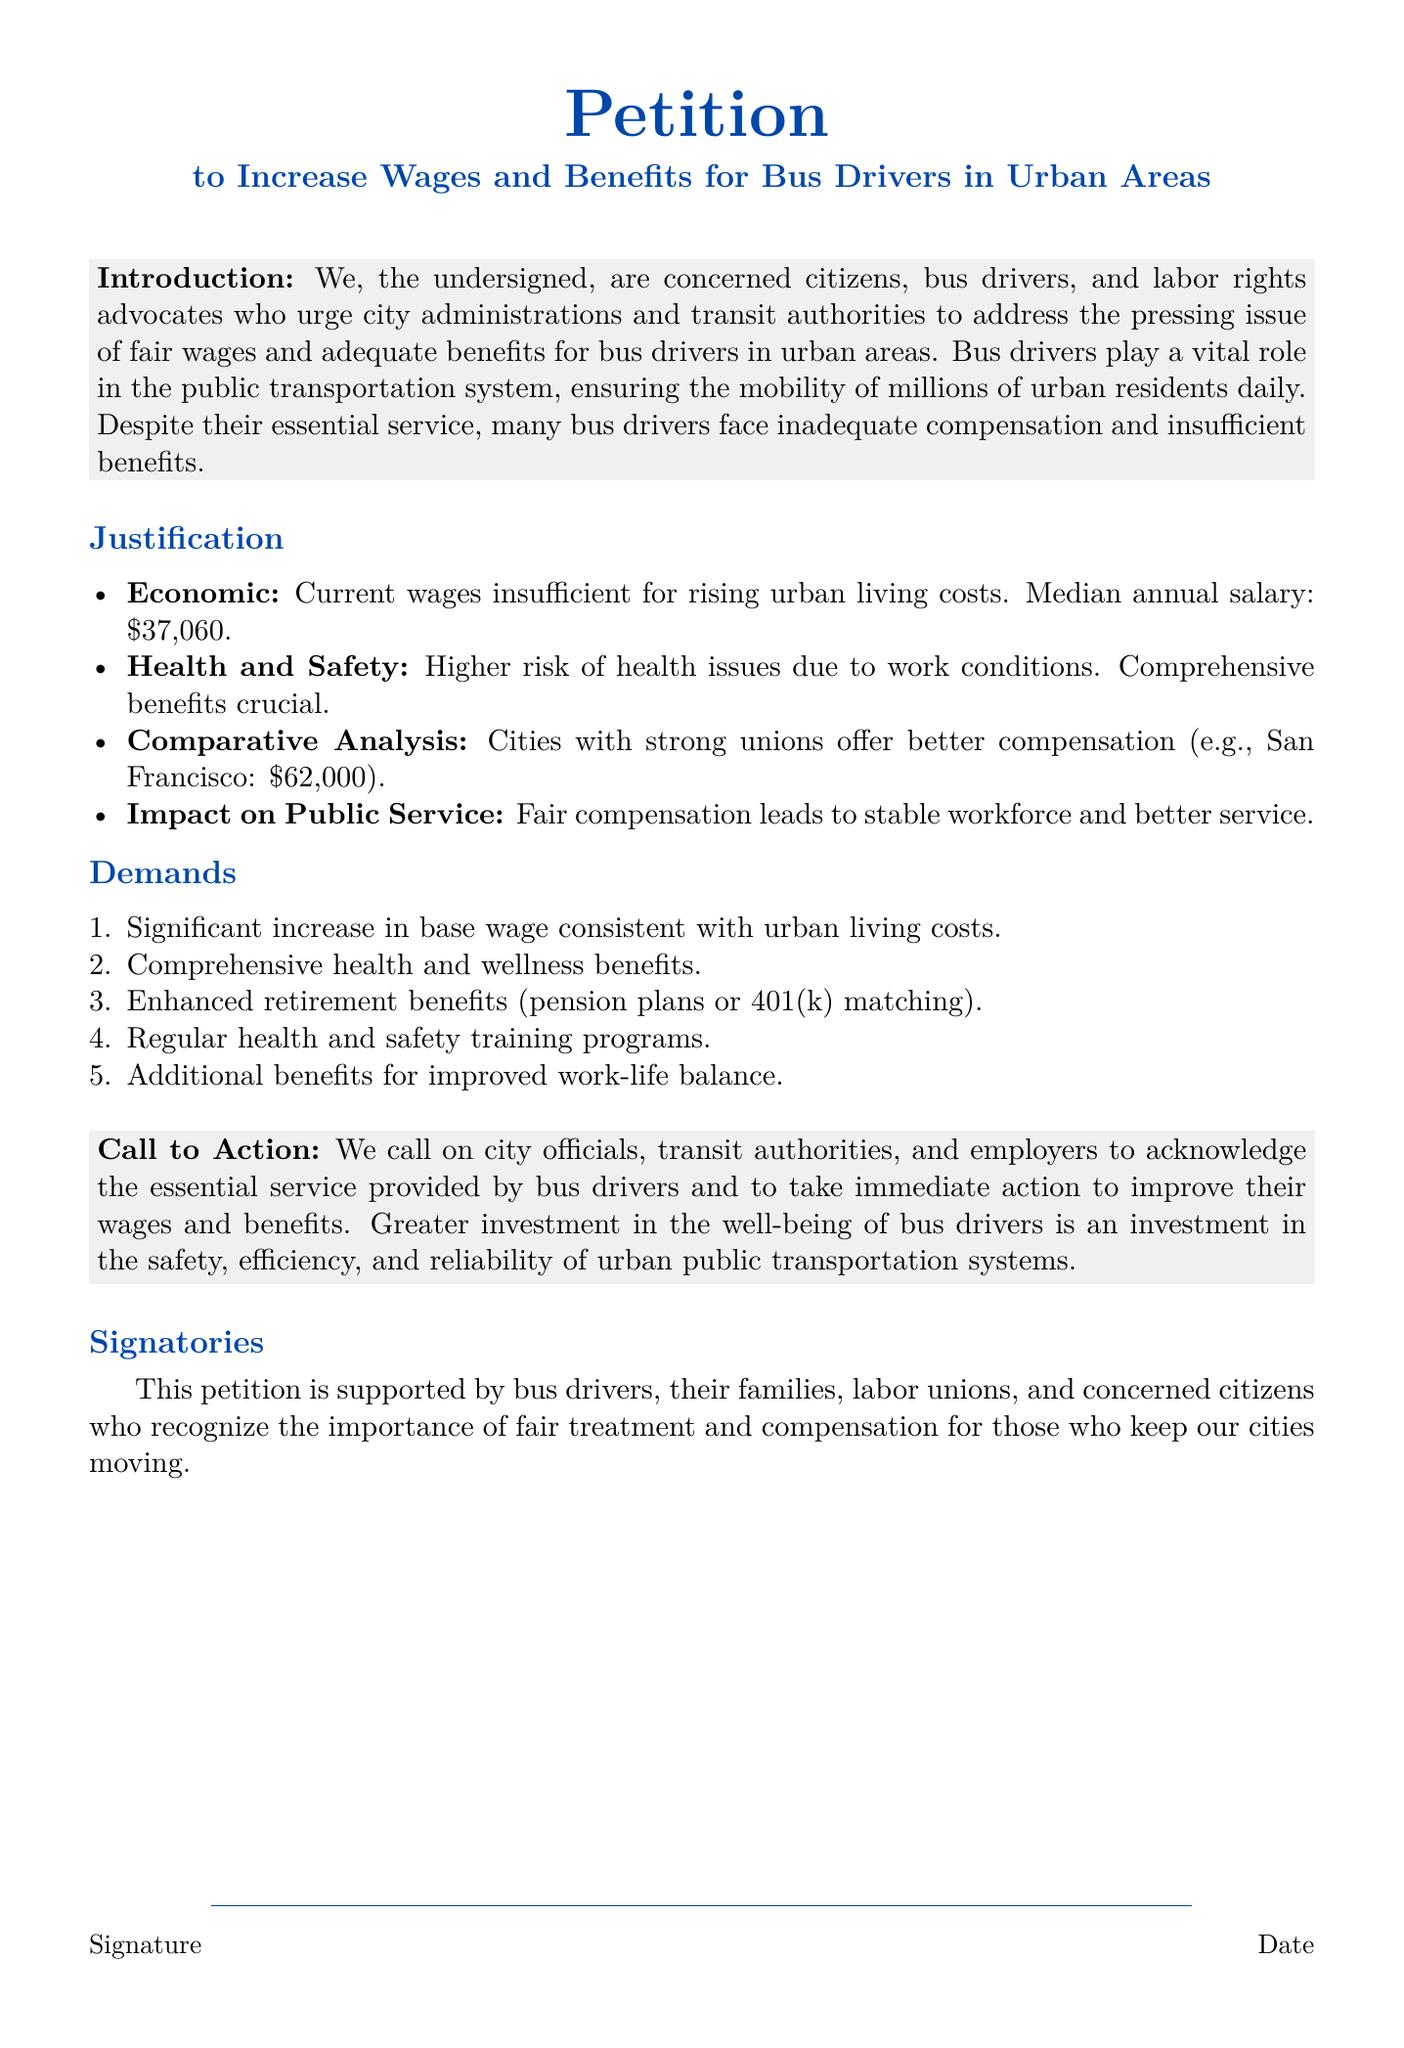What is the title of the petition? The title is found at the top of the document, indicating the purpose of the petition.
Answer: Petition to Increase Wages and Benefits for Bus Drivers in Urban Areas What is the median annual salary of bus drivers mentioned? The document states the median annual salary as part of the justification for the petition.
Answer: $37,060 What is the primary concern of the petitioners? The introduction highlights the main issue being addressed in the petition.
Answer: Fair wages and adequate benefits Which city is mentioned as having better compensation for bus drivers? This information is found in the comparative analysis section of the justification.
Answer: San Francisco How many demands are outlined in the petition? The demands section lists specific requests made by the petitioners.
Answer: Five What is proposed for the improvement of health and safety? The specific item from the demands section addresses health and safety training.
Answer: Regular health and safety training programs What does the petition call on city officials to do? The call to action section indicates the desired outcome from the city officials.
Answer: Acknowledge the essential service provided by bus drivers Who supports the petition? The document specifies the groups and individuals backing the petition.
Answer: Bus drivers, their families, labor unions, and concerned citizens 